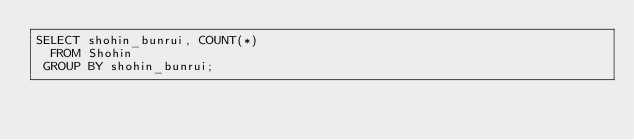Convert code to text. <code><loc_0><loc_0><loc_500><loc_500><_SQL_>SELECT shohin_bunrui, COUNT(*)
  FROM Shohin
 GROUP BY shohin_bunrui;</code> 